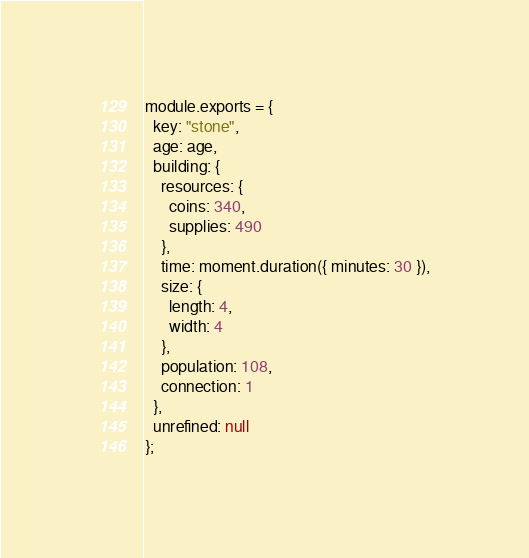Convert code to text. <code><loc_0><loc_0><loc_500><loc_500><_JavaScript_>module.exports = {
  key: "stone",
  age: age,
  building: {
    resources: {
      coins: 340,
      supplies: 490
    },
    time: moment.duration({ minutes: 30 }),
    size: {
      length: 4,
      width: 4
    },
    population: 108,
    connection: 1
  },
  unrefined: null
};
</code> 